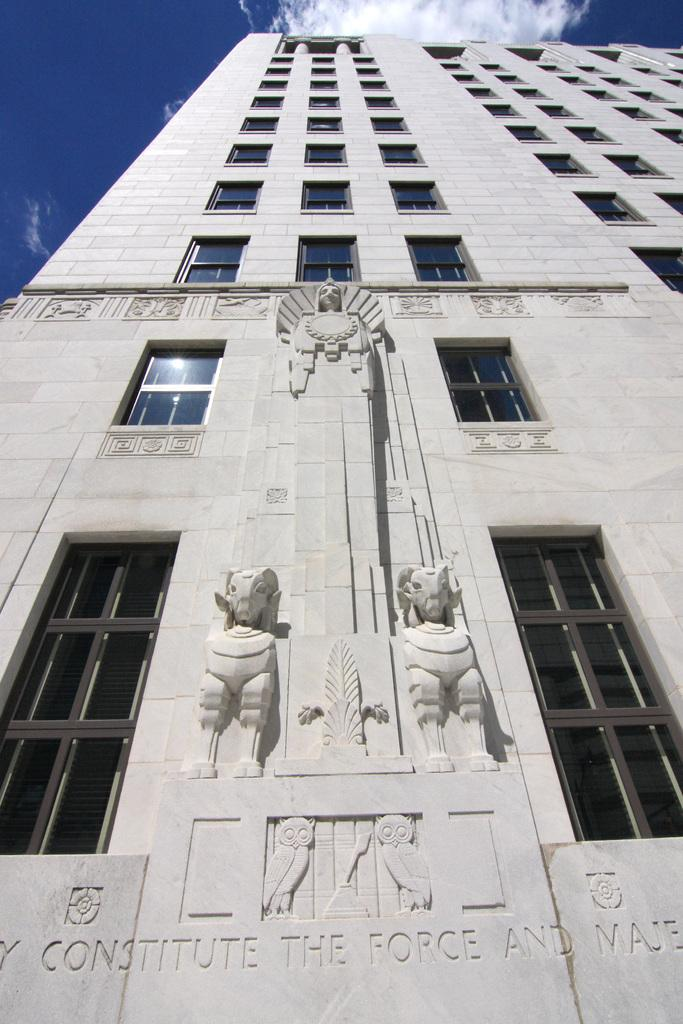What is the main subject in the center of the image? There is a building in the center of the image. What can be seen in the sky at the top of the image? There are clouds visible in the sky at the top of the image. What type of toys are scattered on the floor in the image? There are no toys present in the image; it only features a building and clouds in the sky. 